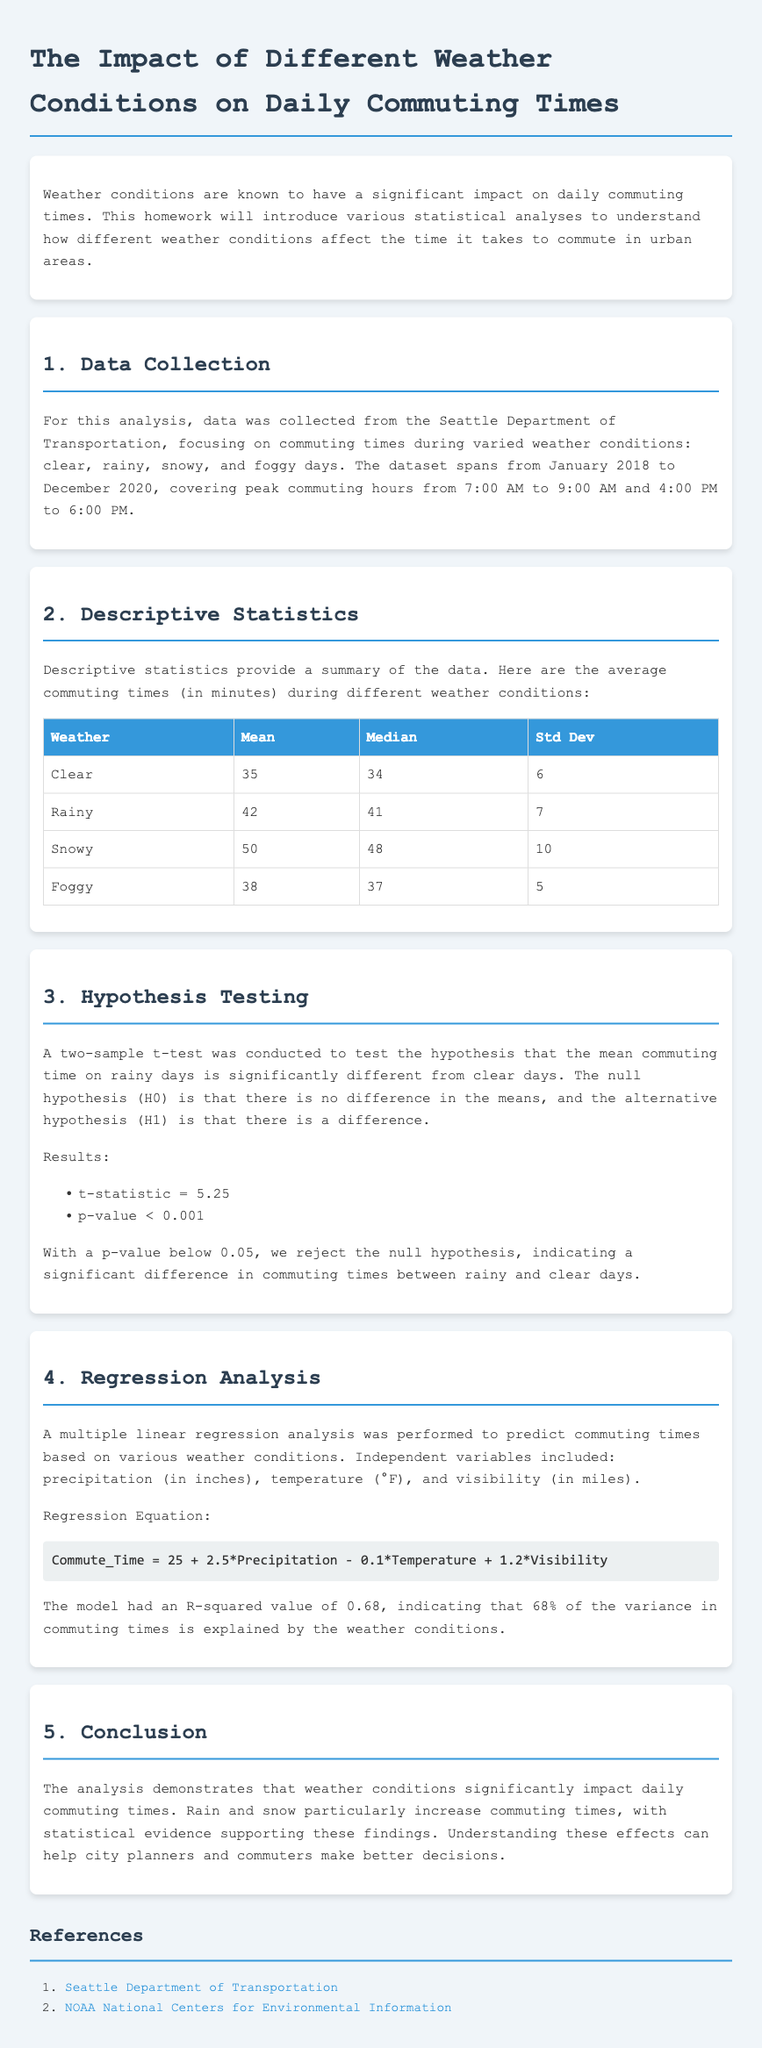What is the title of the homework? The title of the homework is stated at the beginning of the document.
Answer: The Impact of Different Weather Conditions on Daily Commuting Times What are the average commuting times on snowy days? The average commuting time for snowy days is provided in the descriptive statistics section.
Answer: 50 What is the p-value obtained from the t-test? The p-value from the results of the hypothesis testing section is clearly mentioned.
Answer: < 0.001 How much variance in commuting times does the model explain? The explained variance is stated in the regression analysis section with the R-squared value.
Answer: 68% What is the null hypothesis for the t-test conducted? The null hypothesis is described in the hypothesis testing section.
Answer: No difference in the means What were the independent variables used in the regression analysis? The independent variables are listed in the regression analysis section.
Answer: Precipitation, Temperature, Visibility What was the standard deviation of commuting times on foggy days? The standard deviation for foggy days is indicated in the table of descriptive statistics.
Answer: 5 What is the regression equation provided in the document? The regression equation is shown in the regression analysis section.
Answer: Commute_Time = 25 + 2.5*Precipitation - 0.1*Temperature + 1.2*Visibility 